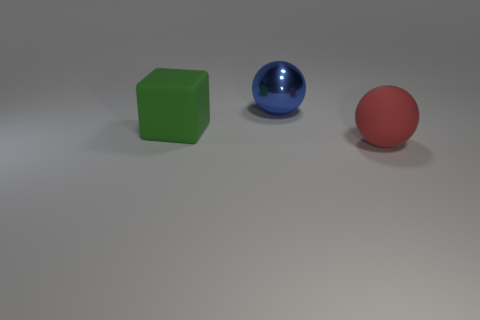There is a blue ball that is the same size as the rubber block; what is it made of?
Make the answer very short. Metal. Are there any other big cubes that have the same material as the big green cube?
Ensure brevity in your answer.  No. Is the number of big green matte blocks that are right of the blue metal ball less than the number of small green objects?
Your response must be concise. No. What is the large sphere that is behind the large matte object behind the red ball made of?
Your answer should be very brief. Metal. The thing that is both right of the large block and in front of the blue ball has what shape?
Offer a very short reply. Sphere. What number of other things are the same color as the big rubber sphere?
Ensure brevity in your answer.  0. How many things are either big objects to the right of the green matte block or green rubber things?
Give a very brief answer. 3. Is the color of the large matte block the same as the big ball on the right side of the big blue shiny thing?
Make the answer very short. No. Is there anything else that is the same size as the blue thing?
Offer a terse response. Yes. There is a rubber thing that is left of the sphere that is in front of the rubber cube; how big is it?
Provide a succinct answer. Large. 